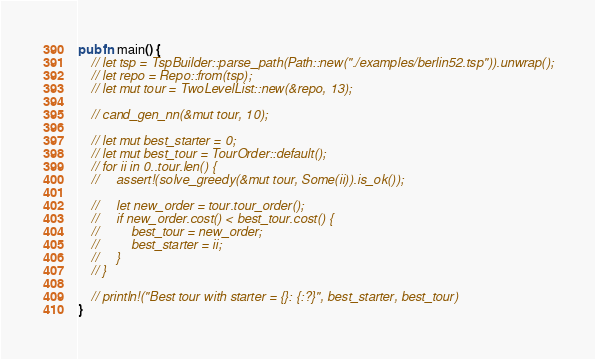<code> <loc_0><loc_0><loc_500><loc_500><_Rust_>pub fn main() {
    // let tsp = TspBuilder::parse_path(Path::new("./examples/berlin52.tsp")).unwrap();
    // let repo = Repo::from(tsp);
    // let mut tour = TwoLevelList::new(&repo, 13);

    // cand_gen_nn(&mut tour, 10);

    // let mut best_starter = 0;
    // let mut best_tour = TourOrder::default();
    // for ii in 0..tour.len() {
    //     assert!(solve_greedy(&mut tour, Some(ii)).is_ok());

    //     let new_order = tour.tour_order();
    //     if new_order.cost() < best_tour.cost() {
    //         best_tour = new_order;
    //         best_starter = ii;
    //     }
    // }

    // println!("Best tour with starter = {}: {:?}", best_starter, best_tour)
}
</code> 